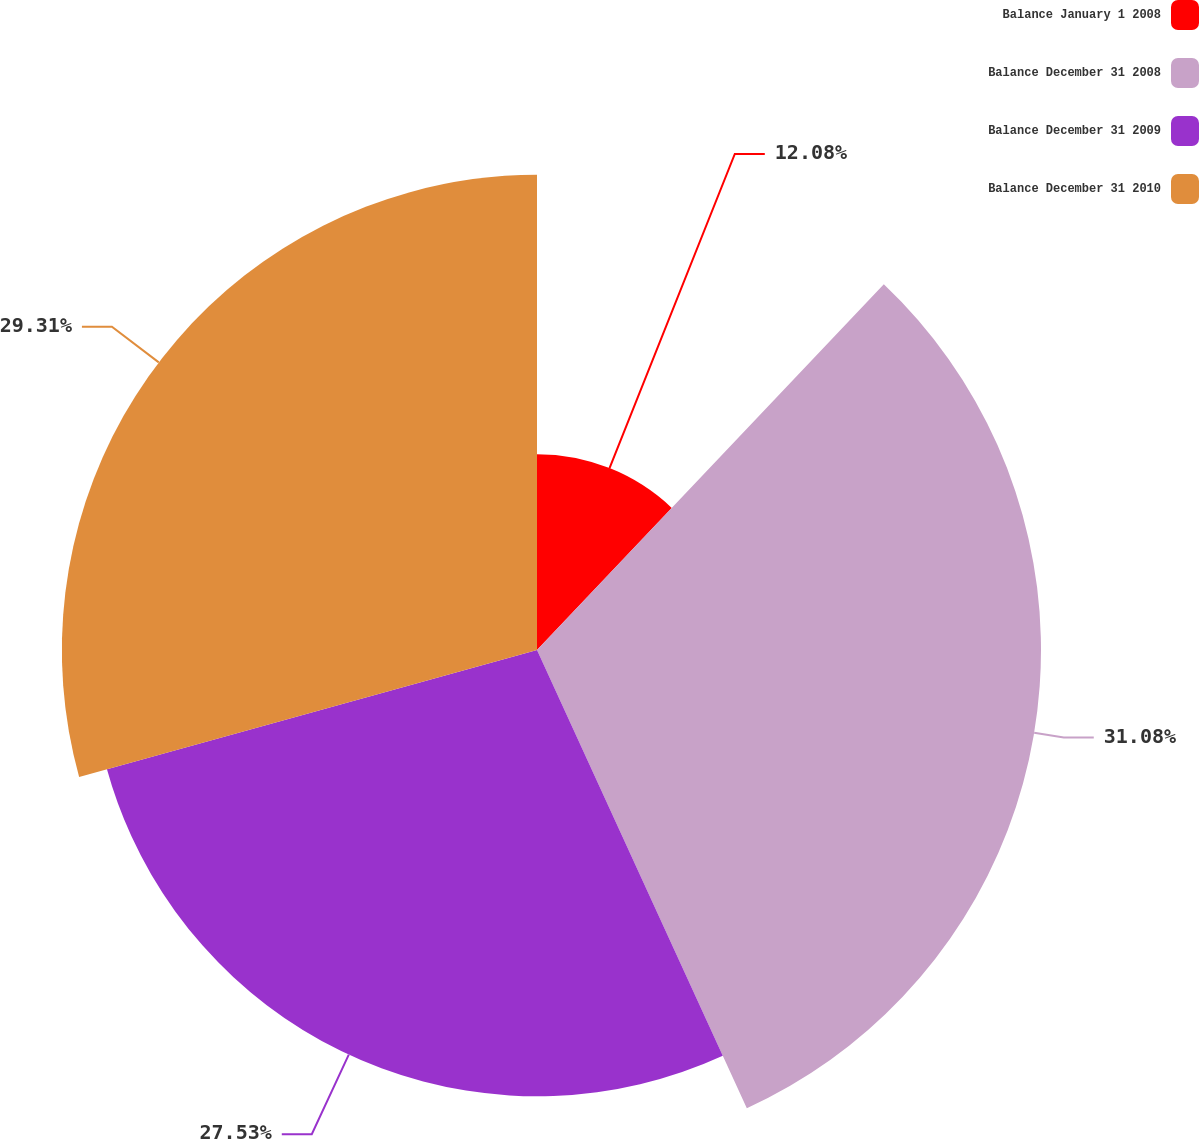Convert chart to OTSL. <chart><loc_0><loc_0><loc_500><loc_500><pie_chart><fcel>Balance January 1 2008<fcel>Balance December 31 2008<fcel>Balance December 31 2009<fcel>Balance December 31 2010<nl><fcel>12.08%<fcel>31.09%<fcel>27.53%<fcel>29.31%<nl></chart> 